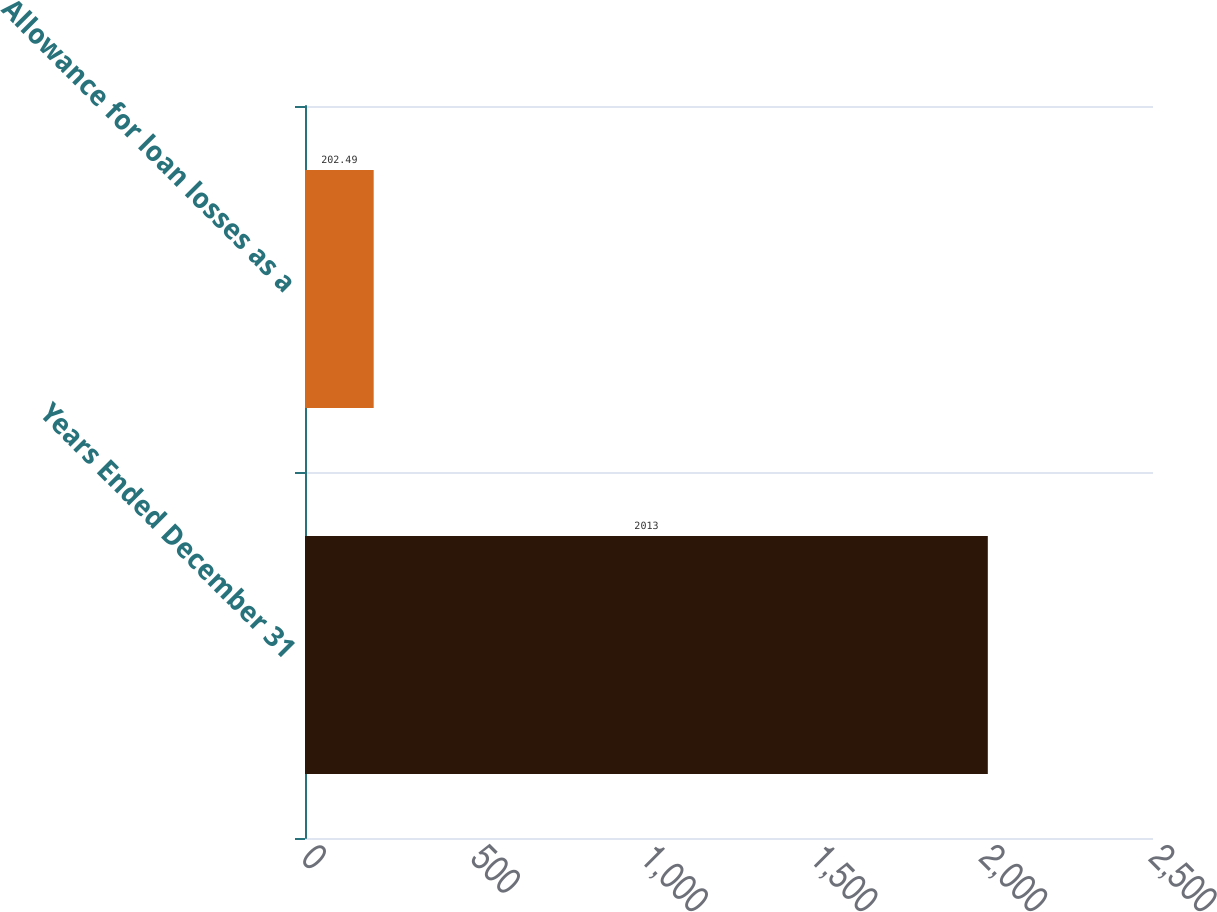<chart> <loc_0><loc_0><loc_500><loc_500><bar_chart><fcel>Years Ended December 31<fcel>Allowance for loan losses as a<nl><fcel>2013<fcel>202.49<nl></chart> 